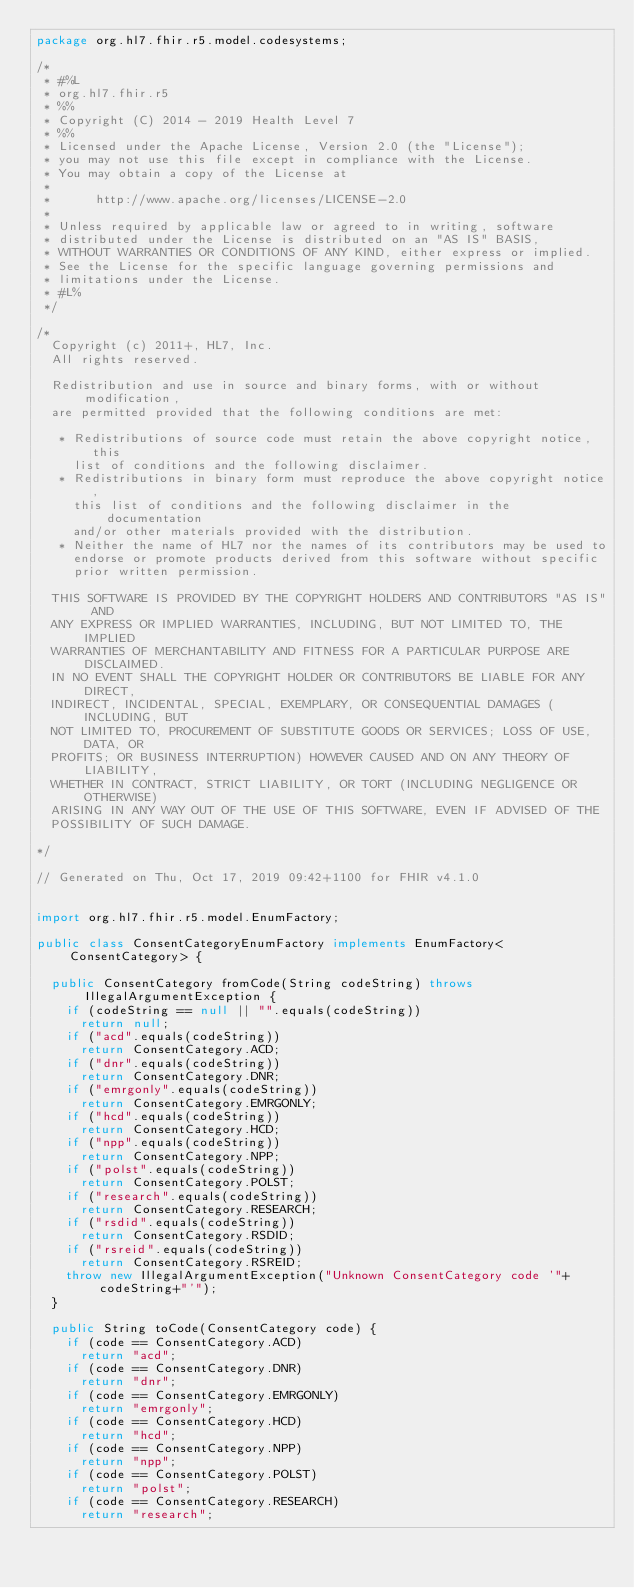<code> <loc_0><loc_0><loc_500><loc_500><_Java_>package org.hl7.fhir.r5.model.codesystems;

/*
 * #%L
 * org.hl7.fhir.r5
 * %%
 * Copyright (C) 2014 - 2019 Health Level 7
 * %%
 * Licensed under the Apache License, Version 2.0 (the "License");
 * you may not use this file except in compliance with the License.
 * You may obtain a copy of the License at
 * 
 *      http://www.apache.org/licenses/LICENSE-2.0
 * 
 * Unless required by applicable law or agreed to in writing, software
 * distributed under the License is distributed on an "AS IS" BASIS,
 * WITHOUT WARRANTIES OR CONDITIONS OF ANY KIND, either express or implied.
 * See the License for the specific language governing permissions and
 * limitations under the License.
 * #L%
 */

/*
  Copyright (c) 2011+, HL7, Inc.
  All rights reserved.
  
  Redistribution and use in source and binary forms, with or without modification, 
  are permitted provided that the following conditions are met:
  
   * Redistributions of source code must retain the above copyright notice, this 
     list of conditions and the following disclaimer.
   * Redistributions in binary form must reproduce the above copyright notice, 
     this list of conditions and the following disclaimer in the documentation 
     and/or other materials provided with the distribution.
   * Neither the name of HL7 nor the names of its contributors may be used to 
     endorse or promote products derived from this software without specific 
     prior written permission.
  
  THIS SOFTWARE IS PROVIDED BY THE COPYRIGHT HOLDERS AND CONTRIBUTORS "AS IS" AND 
  ANY EXPRESS OR IMPLIED WARRANTIES, INCLUDING, BUT NOT LIMITED TO, THE IMPLIED 
  WARRANTIES OF MERCHANTABILITY AND FITNESS FOR A PARTICULAR PURPOSE ARE DISCLAIMED. 
  IN NO EVENT SHALL THE COPYRIGHT HOLDER OR CONTRIBUTORS BE LIABLE FOR ANY DIRECT, 
  INDIRECT, INCIDENTAL, SPECIAL, EXEMPLARY, OR CONSEQUENTIAL DAMAGES (INCLUDING, BUT 
  NOT LIMITED TO, PROCUREMENT OF SUBSTITUTE GOODS OR SERVICES; LOSS OF USE, DATA, OR 
  PROFITS; OR BUSINESS INTERRUPTION) HOWEVER CAUSED AND ON ANY THEORY OF LIABILITY, 
  WHETHER IN CONTRACT, STRICT LIABILITY, OR TORT (INCLUDING NEGLIGENCE OR OTHERWISE) 
  ARISING IN ANY WAY OUT OF THE USE OF THIS SOFTWARE, EVEN IF ADVISED OF THE 
  POSSIBILITY OF SUCH DAMAGE.
  
*/

// Generated on Thu, Oct 17, 2019 09:42+1100 for FHIR v4.1.0


import org.hl7.fhir.r5.model.EnumFactory;

public class ConsentCategoryEnumFactory implements EnumFactory<ConsentCategory> {

  public ConsentCategory fromCode(String codeString) throws IllegalArgumentException {
    if (codeString == null || "".equals(codeString))
      return null;
    if ("acd".equals(codeString))
      return ConsentCategory.ACD;
    if ("dnr".equals(codeString))
      return ConsentCategory.DNR;
    if ("emrgonly".equals(codeString))
      return ConsentCategory.EMRGONLY;
    if ("hcd".equals(codeString))
      return ConsentCategory.HCD;
    if ("npp".equals(codeString))
      return ConsentCategory.NPP;
    if ("polst".equals(codeString))
      return ConsentCategory.POLST;
    if ("research".equals(codeString))
      return ConsentCategory.RESEARCH;
    if ("rsdid".equals(codeString))
      return ConsentCategory.RSDID;
    if ("rsreid".equals(codeString))
      return ConsentCategory.RSREID;
    throw new IllegalArgumentException("Unknown ConsentCategory code '"+codeString+"'");
  }

  public String toCode(ConsentCategory code) {
    if (code == ConsentCategory.ACD)
      return "acd";
    if (code == ConsentCategory.DNR)
      return "dnr";
    if (code == ConsentCategory.EMRGONLY)
      return "emrgonly";
    if (code == ConsentCategory.HCD)
      return "hcd";
    if (code == ConsentCategory.NPP)
      return "npp";
    if (code == ConsentCategory.POLST)
      return "polst";
    if (code == ConsentCategory.RESEARCH)
      return "research";</code> 